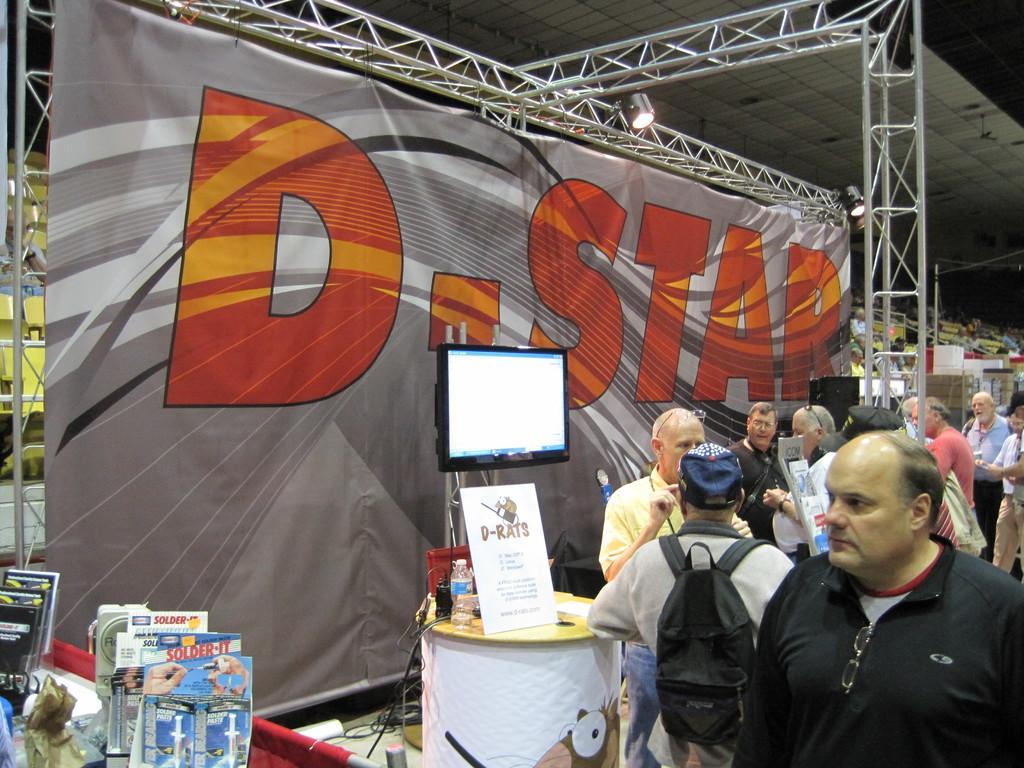In one or two sentences, can you explain what this image depicts? In this picture I can see group of people standing, there is a television, there are some objects on the tables, there is a banner, lighting truss, there are focus lights, chairs, and in the background there are some objects. 